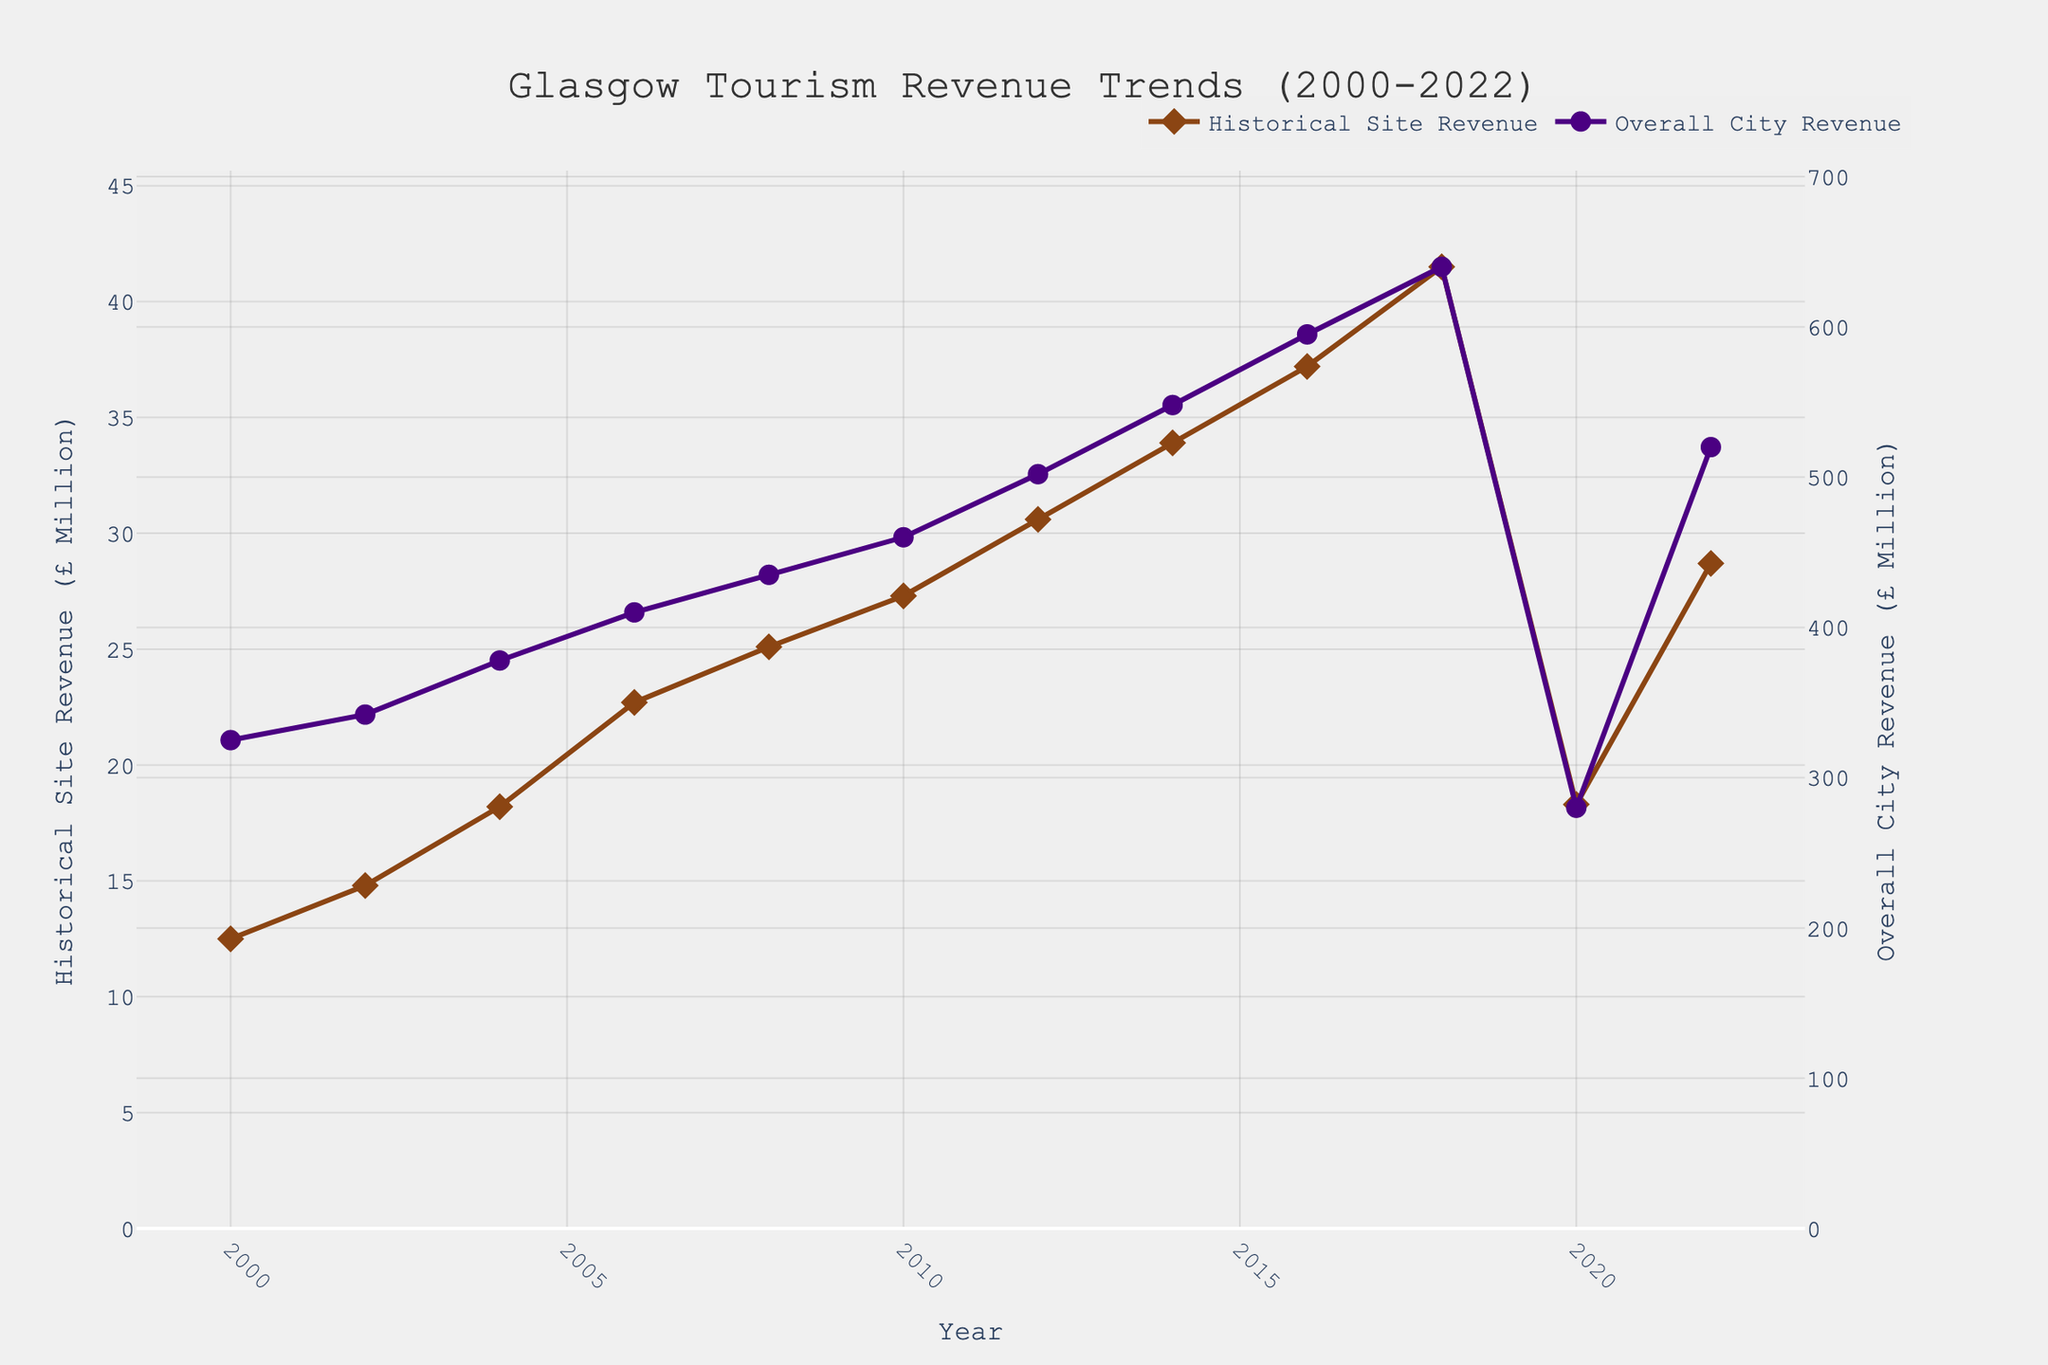What trend is observed for the historical site tourism revenue from 2000 to 2018? From 2000 to 2018, the line representing historical site tourism revenue shows a consistent increase year by year without any significant drops.
Answer: Continuous increase What happened to the overall city tourism revenue between 2000 and 2020? The overall city tourism revenue increased steadily from 2000 to 2018, but there is a significant drop from 640 million in 2018 to 280 million in 2020.
Answer: Steady increase followed by a sharp decline By how much did the historical site tourism revenue drop from its peak in 2018 to the lowest point in 2020? The historical site tourism revenue peaked at 41.5 million in 2018 and dropped to 18.3 million in 2020. The difference is 41.5 - 18.3 = 23.2 million.
Answer: 23.2 million Which year has the highest overall city tourism revenue? The plot demonstrates that the highest overall city tourism revenue is observed in 2018.
Answer: 2018 Compare the growth rates of historical site and overall city tourism revenue from 2002 to 2010. In 2002, historical site tourism revenue was 14.8 million and it grew to 27.3 million in 2010, an increase of 27.3 - 14.8 = 12.5 million. The overall city tourism revenue was 342 million in 2002 and grew to 460 million in 2010, an increase of 460 - 342 = 118 million. Comparing these growth rates, they both show strong growth, but overall city tourism revenue grew more significantly.
Answer: Overall city revenue grew more Did both revenue streams show a similar trend in 2022? Yes, both historical site and overall city tourism revenue recovered in 2022 after the drop in 2020, showing an increase to 28.7 million and 520 million respectively.
Answer: Yes In which years did both historical site and overall city tourism revenues both show a clear increase? Both revenues show a clear increase in almost all years from 2000 to 2018 except for 2020 where both decreased. They increased in 2002, 2004, 2006, 2008, 2010, 2012, 2014, 2016, and 2018.
Answer: 2002, 2004, 2006, 2008, 2010, 2012, 2014, 2016, 2018 What is the ratio of overall city tourism revenue to historical site tourism revenue in 2006? In 2006, historical site tourism revenue was 22.7 million and overall city tourism revenue was 410 million. The ratio is 410 / 22.7 ≈ 18.1.
Answer: 18.1 What's the average overall city tourism revenue during the period from 2000 to 2022? Summing up the overall city tourism revenue from 2000 to 2022 gives 325 + 342 + 378 + 410 + 435 + 460 + 502 + 548 + 595 + 640 + 280 + 520 = 5435 million. Dividing by the number of years (12), the average is 5435 / 12 ≈ 452.92 million.
Answer: 452.92 million 